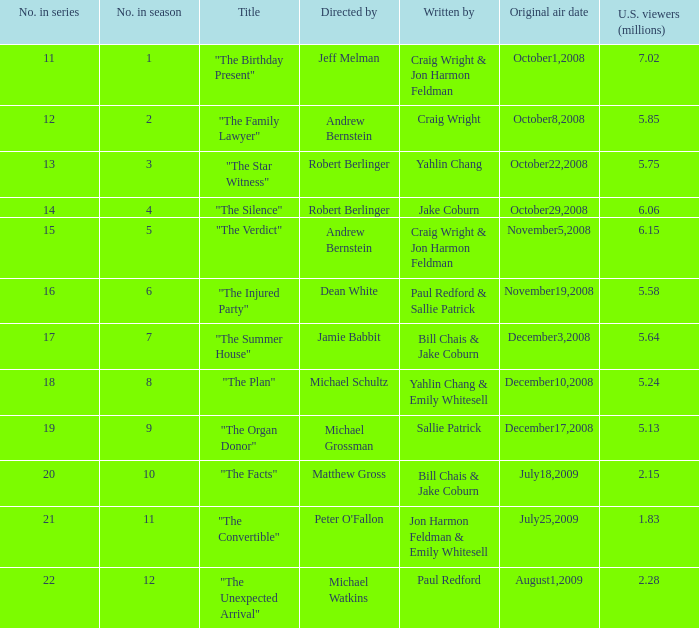Would you be able to parse every entry in this table? {'header': ['No. in series', 'No. in season', 'Title', 'Directed by', 'Written by', 'Original air date', 'U.S. viewers (millions)'], 'rows': [['11', '1', '"The Birthday Present"', 'Jeff Melman', 'Craig Wright & Jon Harmon Feldman', 'October1,2008', '7.02'], ['12', '2', '"The Family Lawyer"', 'Andrew Bernstein', 'Craig Wright', 'October8,2008', '5.85'], ['13', '3', '"The Star Witness"', 'Robert Berlinger', 'Yahlin Chang', 'October22,2008', '5.75'], ['14', '4', '"The Silence"', 'Robert Berlinger', 'Jake Coburn', 'October29,2008', '6.06'], ['15', '5', '"The Verdict"', 'Andrew Bernstein', 'Craig Wright & Jon Harmon Feldman', 'November5,2008', '6.15'], ['16', '6', '"The Injured Party"', 'Dean White', 'Paul Redford & Sallie Patrick', 'November19,2008', '5.58'], ['17', '7', '"The Summer House"', 'Jamie Babbit', 'Bill Chais & Jake Coburn', 'December3,2008', '5.64'], ['18', '8', '"The Plan"', 'Michael Schultz', 'Yahlin Chang & Emily Whitesell', 'December10,2008', '5.24'], ['19', '9', '"The Organ Donor"', 'Michael Grossman', 'Sallie Patrick', 'December17,2008', '5.13'], ['20', '10', '"The Facts"', 'Matthew Gross', 'Bill Chais & Jake Coburn', 'July18,2009', '2.15'], ['21', '11', '"The Convertible"', "Peter O'Fallon", 'Jon Harmon Feldman & Emily Whitesell', 'July25,2009', '1.83'], ['22', '12', '"The Unexpected Arrival"', 'Michael Watkins', 'Paul Redford', 'August1,2009', '2.28']]} Who wrote the episode that received 1.83 million U.S. viewers? Jon Harmon Feldman & Emily Whitesell. 